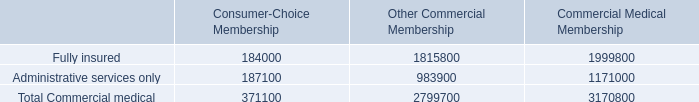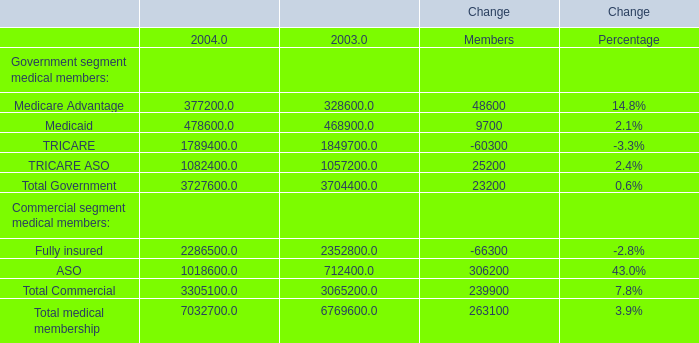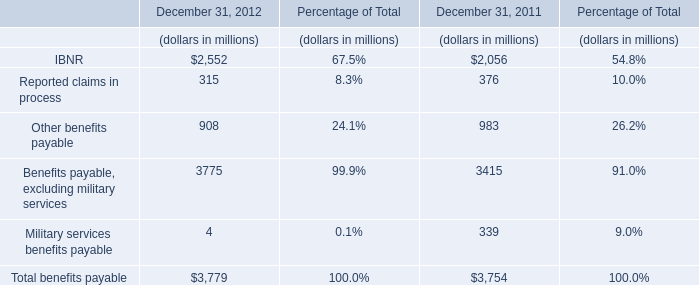What's the greatest value of Government segment medical members in 2003? 
Answer: 1849700. What is the difference between the greatest Government segment medical members in 2003 and 2004？ 
Computations: (1849700 - 1789400)
Answer: 60300.0. 